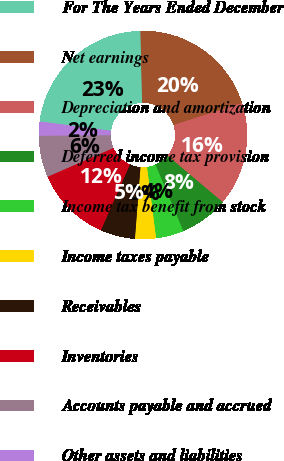Convert chart. <chart><loc_0><loc_0><loc_500><loc_500><pie_chart><fcel>For The Years Ended December<fcel>Net earnings<fcel>Depreciation and amortization<fcel>Deferred income tax provision<fcel>Income tax benefit from stock<fcel>Income taxes payable<fcel>Receivables<fcel>Inventories<fcel>Accounts payable and accrued<fcel>Other assets and liabilities<nl><fcel>22.55%<fcel>20.41%<fcel>16.12%<fcel>7.53%<fcel>4.31%<fcel>3.24%<fcel>5.39%<fcel>11.82%<fcel>6.46%<fcel>2.17%<nl></chart> 